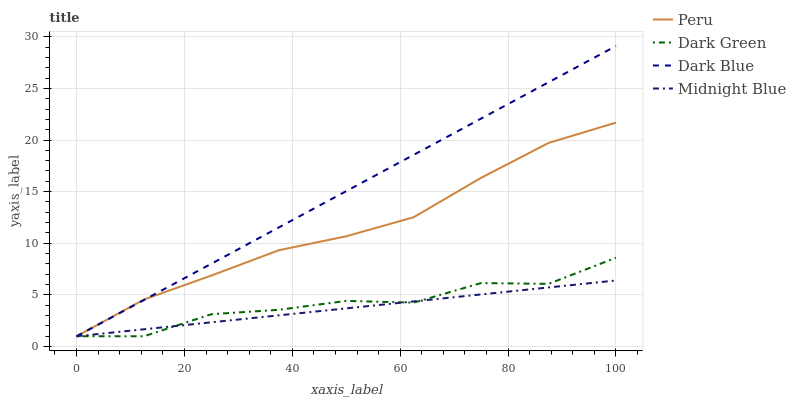Does Midnight Blue have the minimum area under the curve?
Answer yes or no. Yes. Does Dark Blue have the maximum area under the curve?
Answer yes or no. Yes. Does Peru have the minimum area under the curve?
Answer yes or no. No. Does Peru have the maximum area under the curve?
Answer yes or no. No. Is Midnight Blue the smoothest?
Answer yes or no. Yes. Is Dark Green the roughest?
Answer yes or no. Yes. Is Peru the smoothest?
Answer yes or no. No. Is Peru the roughest?
Answer yes or no. No. Does Dark Blue have the lowest value?
Answer yes or no. Yes. Does Dark Blue have the highest value?
Answer yes or no. Yes. Does Peru have the highest value?
Answer yes or no. No. Does Dark Green intersect Midnight Blue?
Answer yes or no. Yes. Is Dark Green less than Midnight Blue?
Answer yes or no. No. Is Dark Green greater than Midnight Blue?
Answer yes or no. No. 